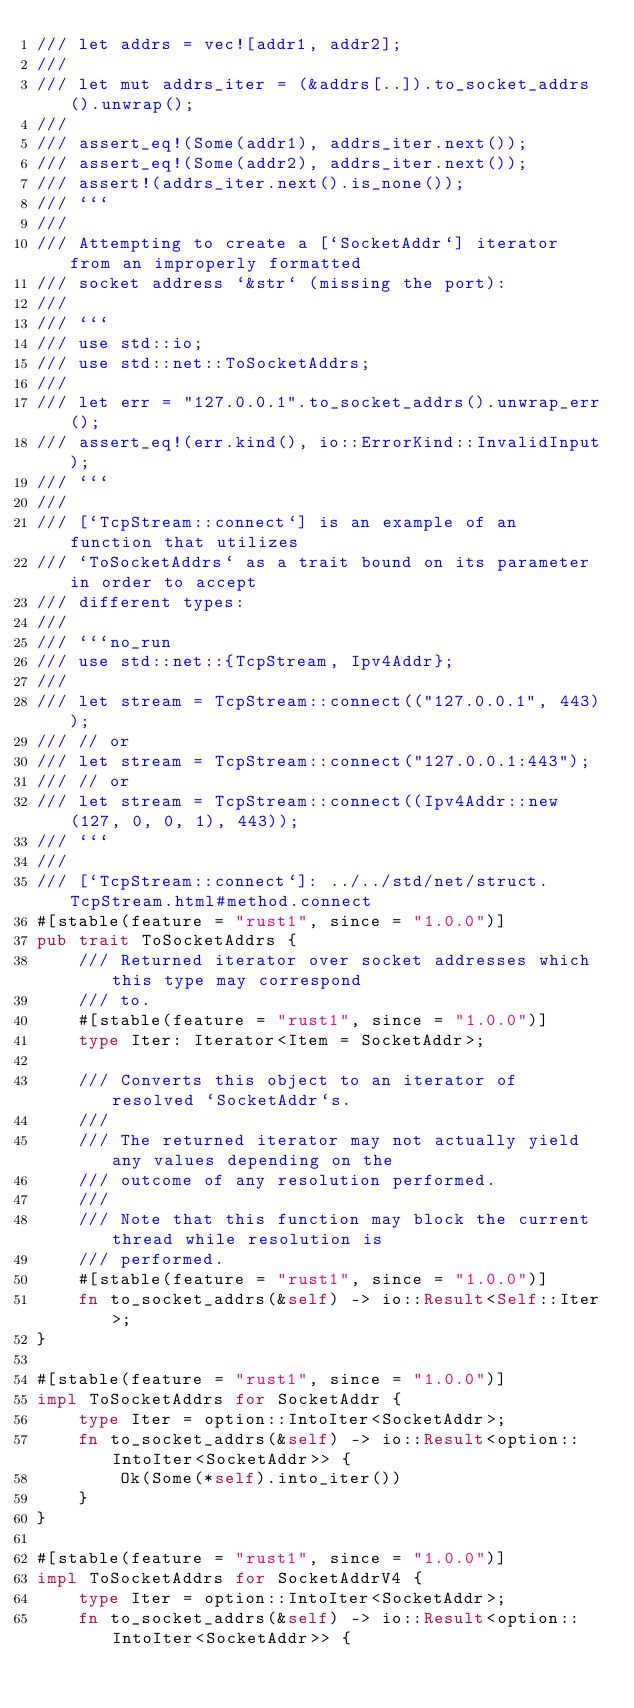Convert code to text. <code><loc_0><loc_0><loc_500><loc_500><_Rust_>/// let addrs = vec![addr1, addr2];
///
/// let mut addrs_iter = (&addrs[..]).to_socket_addrs().unwrap();
///
/// assert_eq!(Some(addr1), addrs_iter.next());
/// assert_eq!(Some(addr2), addrs_iter.next());
/// assert!(addrs_iter.next().is_none());
/// ```
///
/// Attempting to create a [`SocketAddr`] iterator from an improperly formatted
/// socket address `&str` (missing the port):
///
/// ```
/// use std::io;
/// use std::net::ToSocketAddrs;
///
/// let err = "127.0.0.1".to_socket_addrs().unwrap_err();
/// assert_eq!(err.kind(), io::ErrorKind::InvalidInput);
/// ```
///
/// [`TcpStream::connect`] is an example of an function that utilizes
/// `ToSocketAddrs` as a trait bound on its parameter in order to accept
/// different types:
///
/// ```no_run
/// use std::net::{TcpStream, Ipv4Addr};
///
/// let stream = TcpStream::connect(("127.0.0.1", 443));
/// // or
/// let stream = TcpStream::connect("127.0.0.1:443");
/// // or
/// let stream = TcpStream::connect((Ipv4Addr::new(127, 0, 0, 1), 443));
/// ```
///
/// [`TcpStream::connect`]: ../../std/net/struct.TcpStream.html#method.connect
#[stable(feature = "rust1", since = "1.0.0")]
pub trait ToSocketAddrs {
    /// Returned iterator over socket addresses which this type may correspond
    /// to.
    #[stable(feature = "rust1", since = "1.0.0")]
    type Iter: Iterator<Item = SocketAddr>;

    /// Converts this object to an iterator of resolved `SocketAddr`s.
    ///
    /// The returned iterator may not actually yield any values depending on the
    /// outcome of any resolution performed.
    ///
    /// Note that this function may block the current thread while resolution is
    /// performed.
    #[stable(feature = "rust1", since = "1.0.0")]
    fn to_socket_addrs(&self) -> io::Result<Self::Iter>;
}

#[stable(feature = "rust1", since = "1.0.0")]
impl ToSocketAddrs for SocketAddr {
    type Iter = option::IntoIter<SocketAddr>;
    fn to_socket_addrs(&self) -> io::Result<option::IntoIter<SocketAddr>> {
        Ok(Some(*self).into_iter())
    }
}

#[stable(feature = "rust1", since = "1.0.0")]
impl ToSocketAddrs for SocketAddrV4 {
    type Iter = option::IntoIter<SocketAddr>;
    fn to_socket_addrs(&self) -> io::Result<option::IntoIter<SocketAddr>> {</code> 